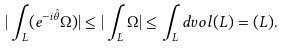<formula> <loc_0><loc_0><loc_500><loc_500>| \int _ { L } ( e ^ { - i \hat { \theta } } \Omega ) | \leq | \int _ { L } \Omega | \leq \int _ { L } d v o l ( L ) = ( L ) .</formula> 